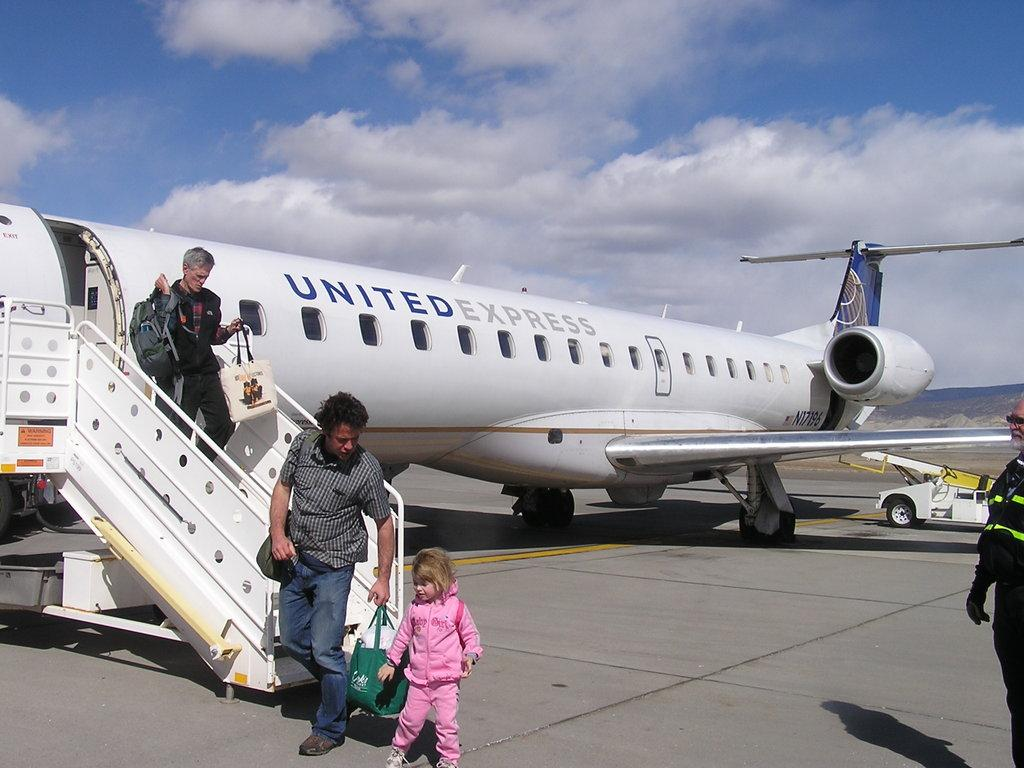<image>
Render a clear and concise summary of the photo. United Express airplane with people getting off the airplane. 